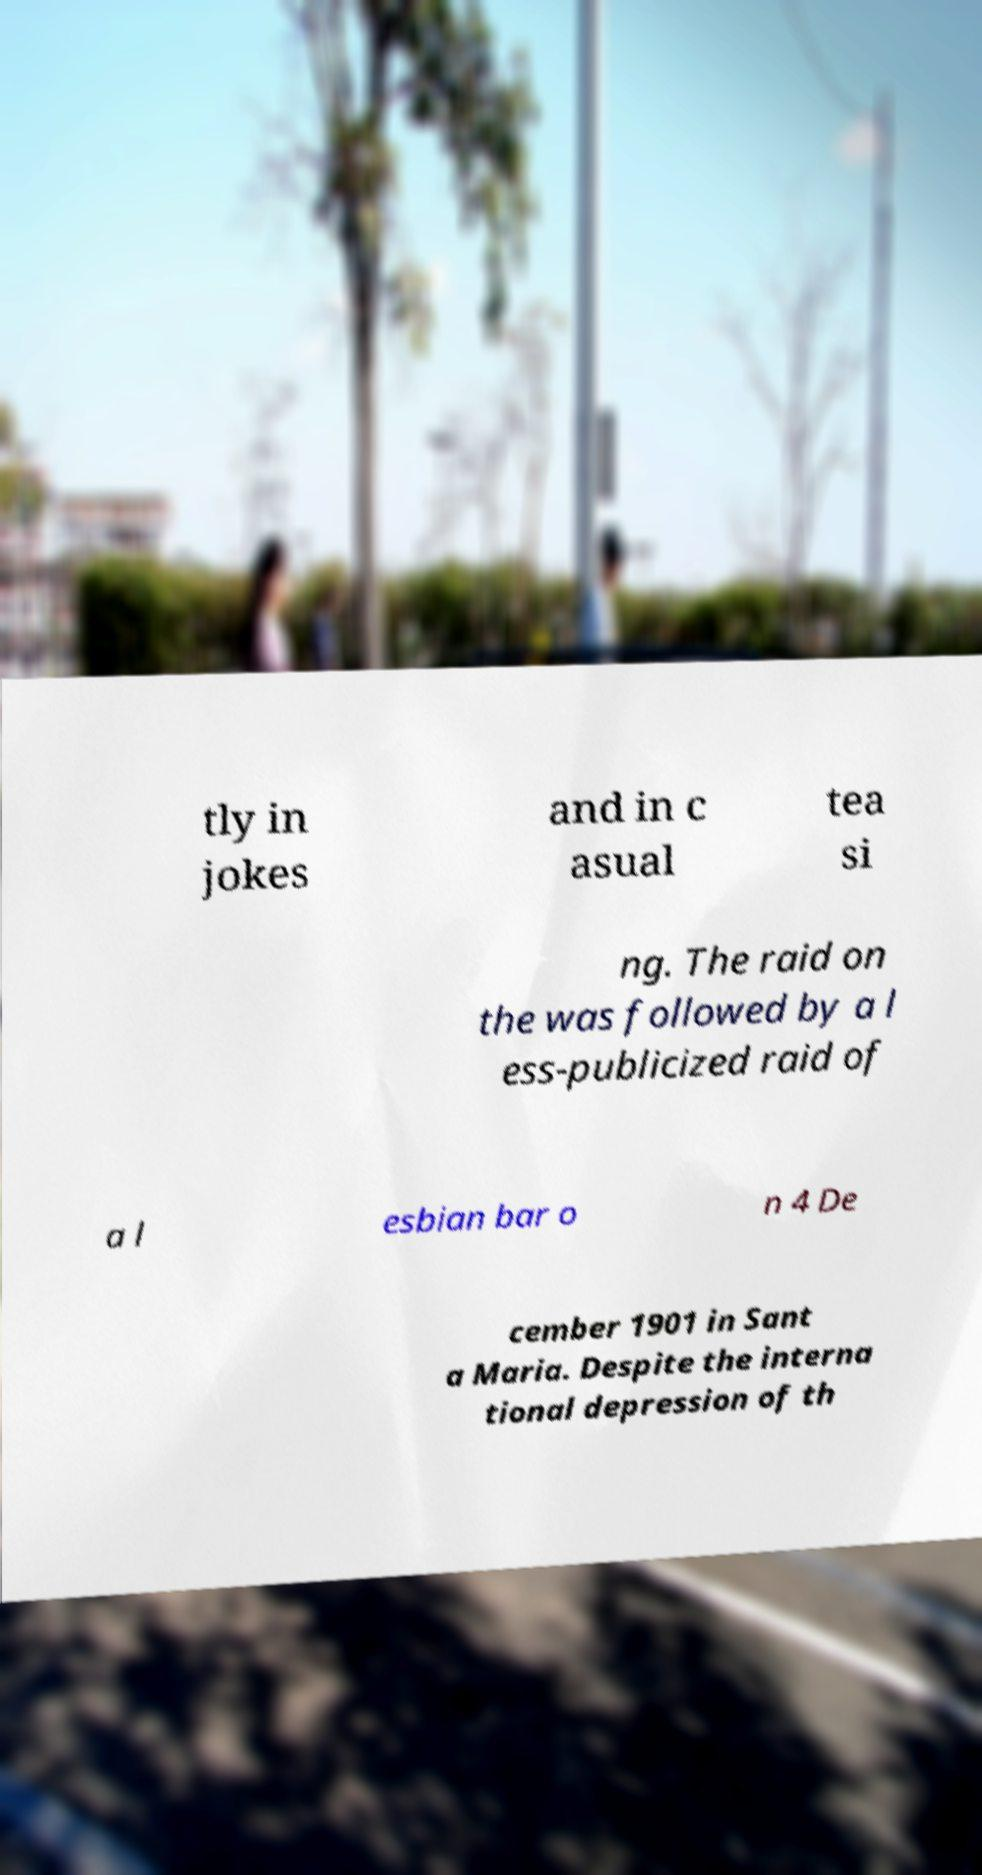For documentation purposes, I need the text within this image transcribed. Could you provide that? tly in jokes and in c asual tea si ng. The raid on the was followed by a l ess-publicized raid of a l esbian bar o n 4 De cember 1901 in Sant a Maria. Despite the interna tional depression of th 